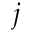Convert formula to latex. <formula><loc_0><loc_0><loc_500><loc_500>j</formula> 